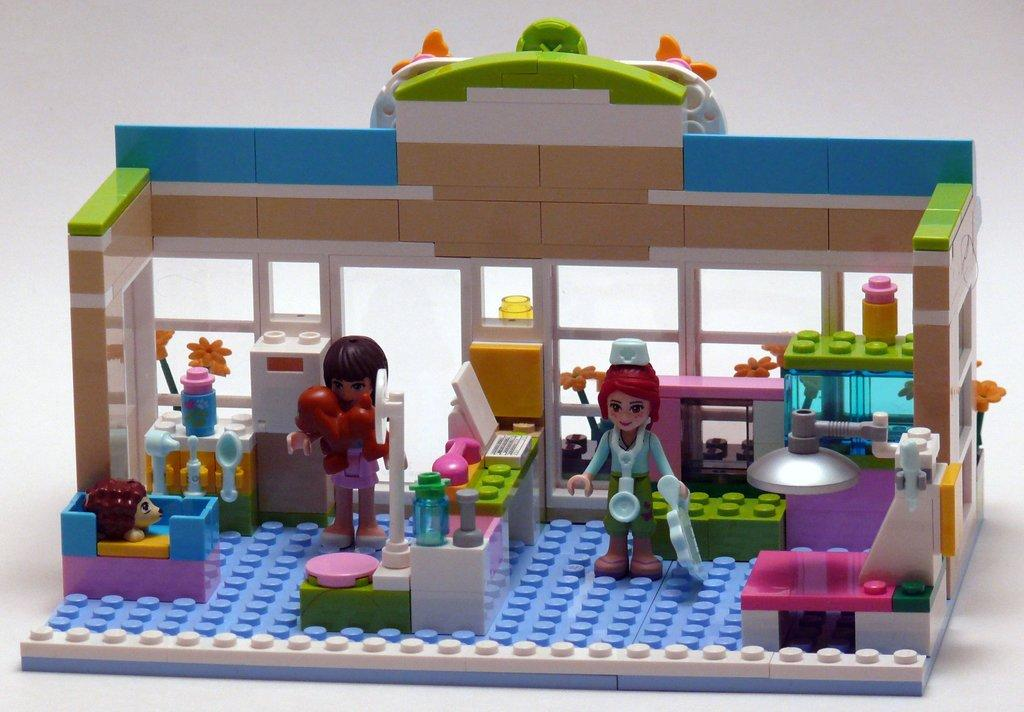What is the main subject in the center of the image? There are Lego toys in the center of the image. What type of support system is in place for the town in the image? There is no town present in the image, only Lego toys. How does the image evoke a feeling of disgust? The image does not evoke a feeling of disgust, as it features Lego toys, which are generally considered to be harmless and fun. 